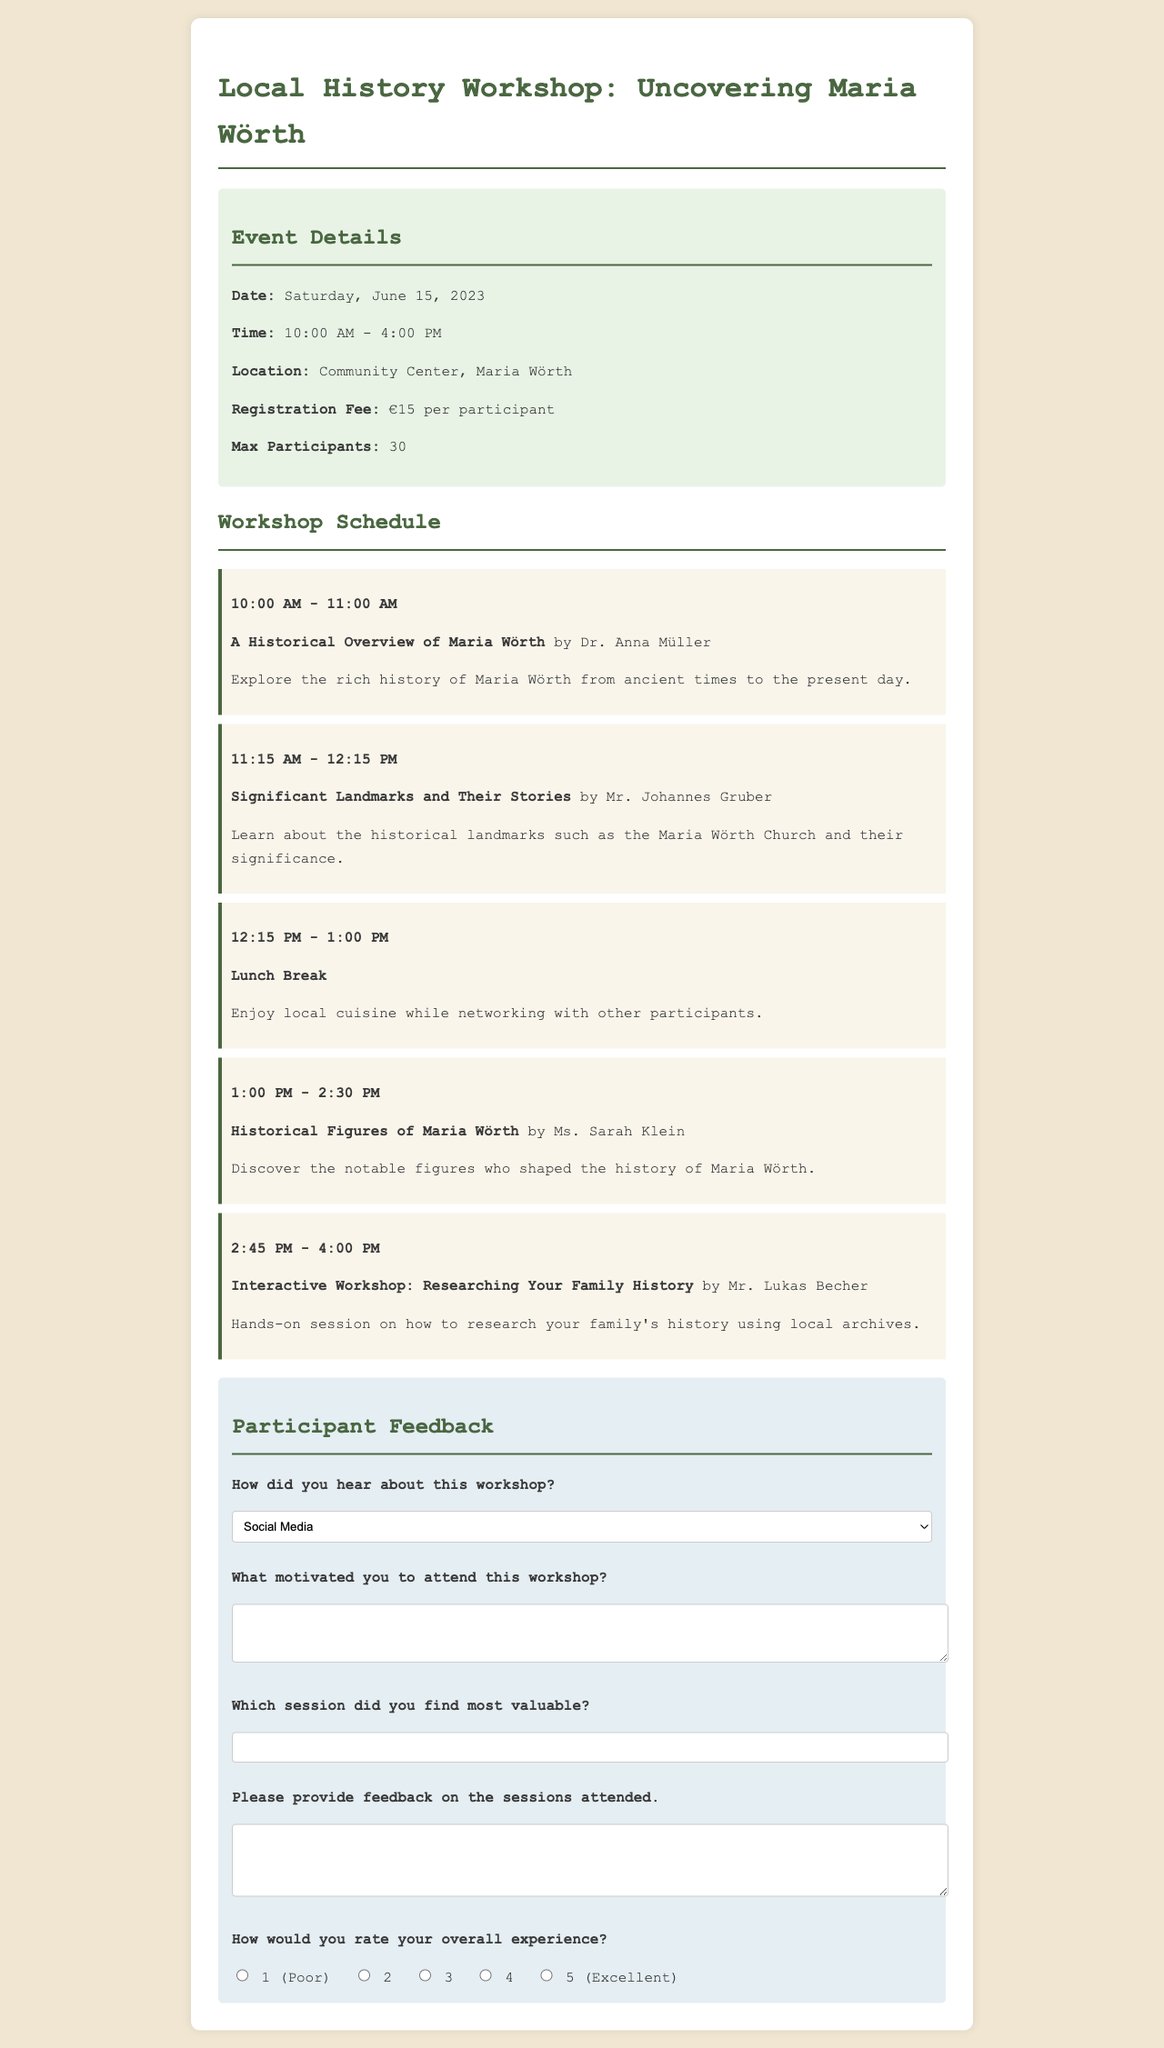What is the date of the workshop? The date of the workshop is indicated in the event details section of the document.
Answer: Saturday, June 15, 2023 What is the registration fee for participants? The registration fee is mentioned clearly in the event details section.
Answer: €15 per participant Who is presenting the session on significant landmarks? The presenter's name for this session is provided alongside the session title in the schedule.
Answer: Mr. Johannes Gruber What time is the lunch break scheduled? The time for the lunch break can be found in the schedule section detailing the various sessions.
Answer: 12:15 PM - 1:00 PM How many participants can attend the workshop? The maximum number of participants is specified in the event details section.
Answer: 30 Which session occurs after the lunch break? The schedule outlines the order of sessions and their timing.
Answer: Historical Figures of Maria Wörth What type of feedback is requested from participants? The types of feedback are specified under the participant feedback section of the document.
Answer: Feedback on sessions attended What is the topic of the first session? The session's title is noted in the schedule and identifies the focus of the first session.
Answer: A Historical Overview of Maria Wörth How would participants rate their overall experience? The document provides a rating scale for participants to express their experience.
Answer: 1 to 5 (with 1 being Poor and 5 being Excellent) 